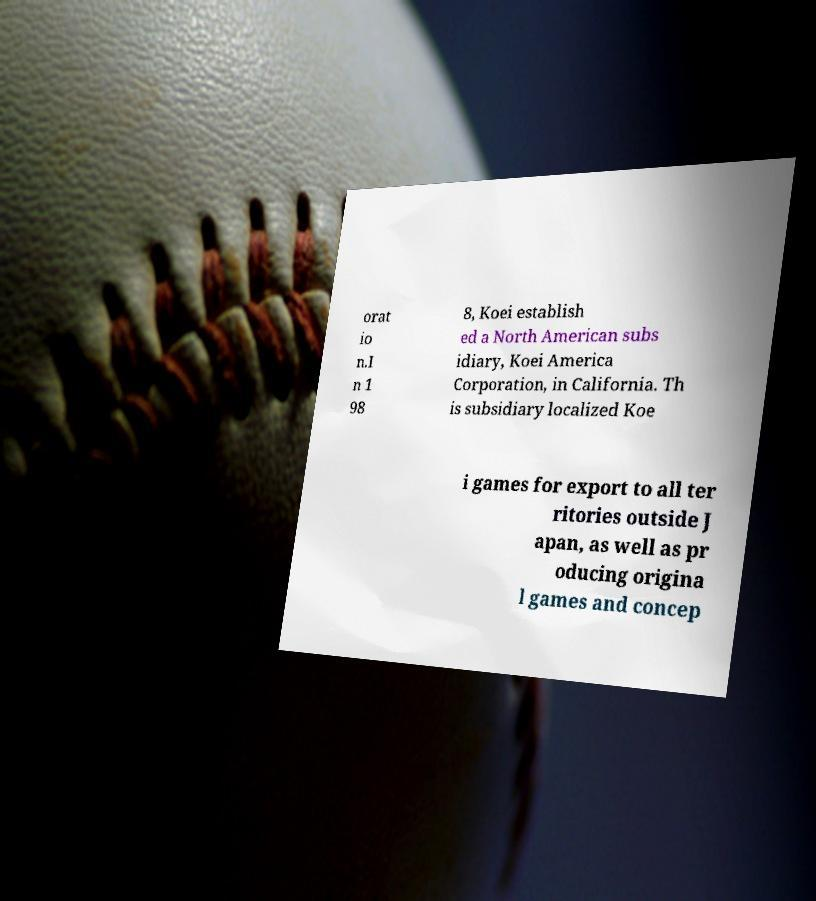What messages or text are displayed in this image? I need them in a readable, typed format. orat io n.I n 1 98 8, Koei establish ed a North American subs idiary, Koei America Corporation, in California. Th is subsidiary localized Koe i games for export to all ter ritories outside J apan, as well as pr oducing origina l games and concep 